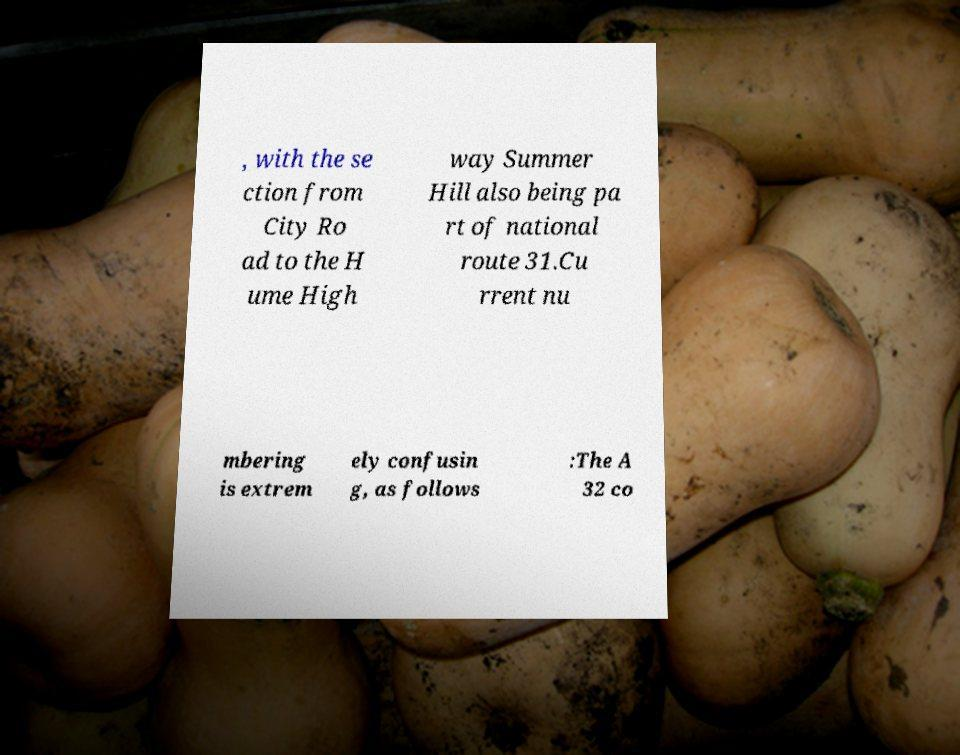I need the written content from this picture converted into text. Can you do that? , with the se ction from City Ro ad to the H ume High way Summer Hill also being pa rt of national route 31.Cu rrent nu mbering is extrem ely confusin g, as follows :The A 32 co 